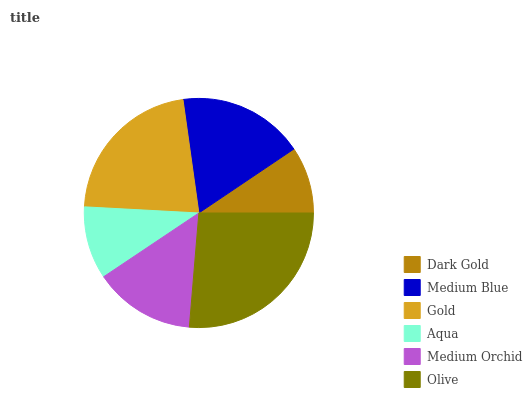Is Dark Gold the minimum?
Answer yes or no. Yes. Is Olive the maximum?
Answer yes or no. Yes. Is Medium Blue the minimum?
Answer yes or no. No. Is Medium Blue the maximum?
Answer yes or no. No. Is Medium Blue greater than Dark Gold?
Answer yes or no. Yes. Is Dark Gold less than Medium Blue?
Answer yes or no. Yes. Is Dark Gold greater than Medium Blue?
Answer yes or no. No. Is Medium Blue less than Dark Gold?
Answer yes or no. No. Is Medium Blue the high median?
Answer yes or no. Yes. Is Medium Orchid the low median?
Answer yes or no. Yes. Is Olive the high median?
Answer yes or no. No. Is Gold the low median?
Answer yes or no. No. 